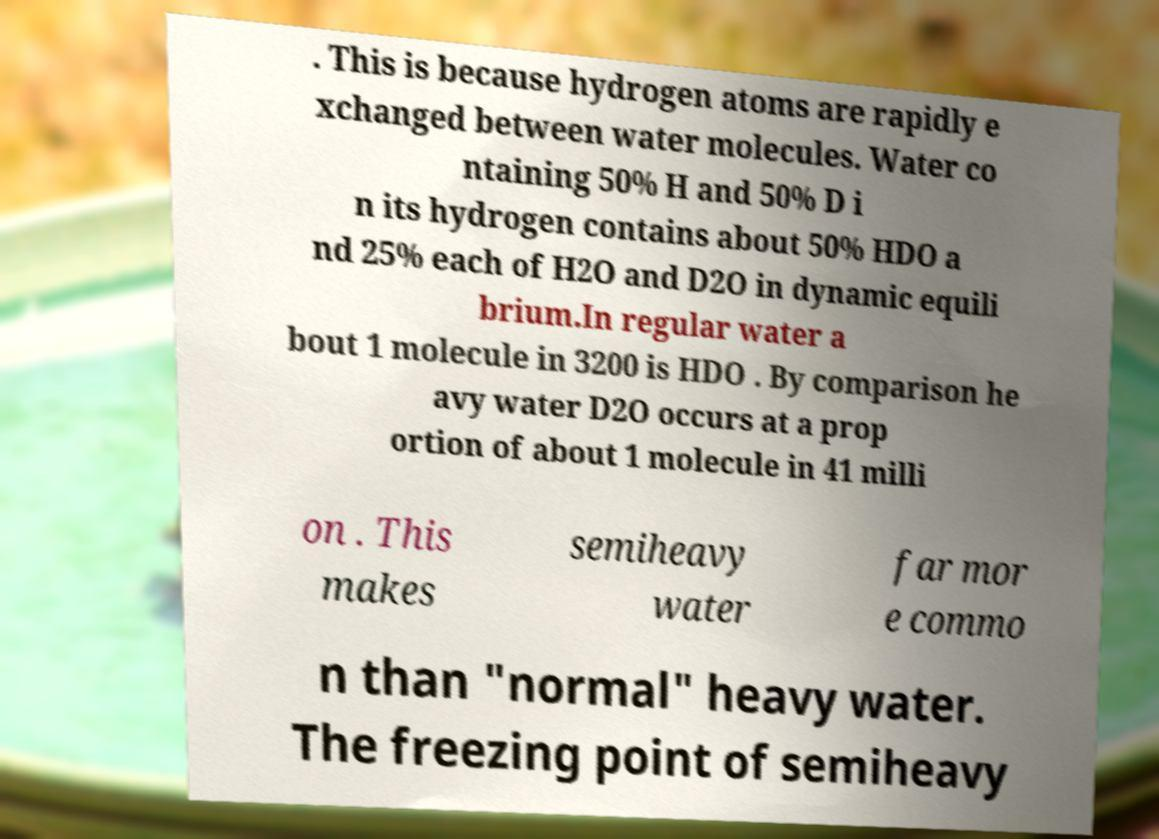Can you read and provide the text displayed in the image?This photo seems to have some interesting text. Can you extract and type it out for me? . This is because hydrogen atoms are rapidly e xchanged between water molecules. Water co ntaining 50% H and 50% D i n its hydrogen contains about 50% HDO a nd 25% each of H2O and D2O in dynamic equili brium.In regular water a bout 1 molecule in 3200 is HDO . By comparison he avy water D2O occurs at a prop ortion of about 1 molecule in 41 milli on . This makes semiheavy water far mor e commo n than "normal" heavy water. The freezing point of semiheavy 